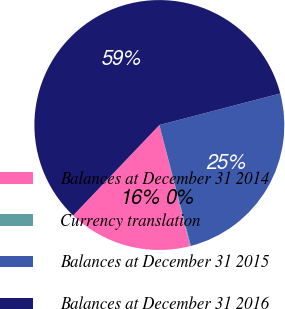Convert chart. <chart><loc_0><loc_0><loc_500><loc_500><pie_chart><fcel>Balances at December 31 2014<fcel>Currency translation<fcel>Balances at December 31 2015<fcel>Balances at December 31 2016<nl><fcel>16.07%<fcel>0.1%<fcel>25.01%<fcel>58.82%<nl></chart> 